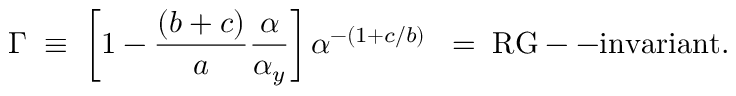<formula> <loc_0><loc_0><loc_500><loc_500>\Gamma \, \equiv \, \left [ 1 - { \frac { ( b + c ) } { a } } { \frac { \alpha } { \alpha _ { y } } } \right ] \alpha ^ { - ( 1 + c / b ) } \, = \, R G - - i n v a r i a n t .</formula> 